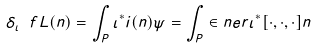<formula> <loc_0><loc_0><loc_500><loc_500>\delta _ { \iota } \ f L ( n ) = \int _ { P } \iota ^ { * } i ( n ) \psi = \int _ { P } \in n e r { \iota ^ { * } [ \cdot , \cdot , \cdot ] } { n }</formula> 